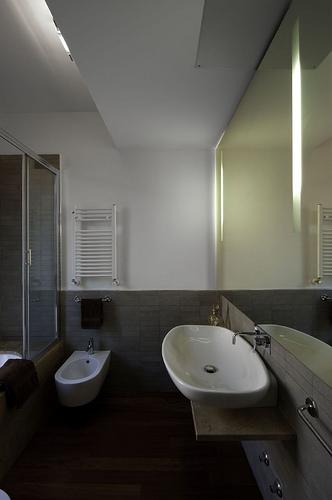Is this a man's bathroom?
Be succinct. Yes. Is this an American bathroom?
Write a very short answer. No. How many sinks are in this picture?
Write a very short answer. 1. Are there any towels pictured?
Concise answer only. Yes. Is that at a strange angle?
Keep it brief. No. 